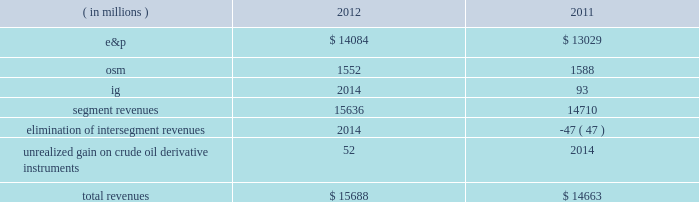Key operating and financial activities significant operating and financial activities during 2012 include : 2022 net proved reserve additions for the e&p and osm segments combined of 389 mmboe , for a 226 percent reserve replacement 2022 increased proved liquid hydrocarbon and synthetic crude oil reserves by 316 mmbbls , for a reserve replacement of 268 percent for these commodities 2022 recorded more than 95 percent average operational availability for operated e&p assets 2022 increased e&p net sales volumes , excluding libya , by 8 percent 2022 eagle ford shale average net sales volumes of 65 mboed for december 2012 , a fourfold increase over december 2011 2022 bakken shale average net sales volumes of 29 mboed , a 71 percent increase over last year 2022 resumed sales from libya and reached pre-conflict production levels 2022 international liquid hydrocarbon sales volumes , for which average realizations have exceeded wti , were 62 percent of net e&p liquid hydrocarbon sales 2022 closed $ 1 billion of acquisitions in the core of the eagle ford shale 2022 assumed operatorship of the vilje field located offshore norway 2022 signed agreements for new exploration positions in e.g. , gabon , kenya and ethiopia 2022 issued $ 1 billion of 3-year senior notes at 0.9 percent interest and $ 1 billion of 10-year senior notes at 2.8 percent interest some significant 2013 activities through february 22 , 2013 include : 2022 closed sale of our alaska assets in january 2013 2022 closed sale of our interest in the neptune gas plant in february 2013 consolidated results of operations : 2012 compared to 2011 consolidated income before income taxes was 38 percent higher in 2012 than consolidated income from continuing operations before income taxes were in 2011 , largely due to higher liquid hydrocarbon sales volumes in our e&p segment , partially offset by lower earnings from our osm and ig segments .
The 7 percent decrease in income from continuing operations included lower earnings in the u.k .
And e.g. , partially offset by higher earnings in libya .
Also , in 2011 we were not in an excess foreign tax credit position for the entire year as we were in 2012 .
The effective income tax rate for continuing operations was 74 percent in 2012 compared to 61 percent in 2011 .
Revenues are summarized in the table: .
E&p segment revenues increased $ 1055 million from 2011 to 2012 , primarily due to higher average liquid hydrocarbon sales volumes .
E&p segment revenues included a net realized gain on crude oil derivative instruments of $ 15 million in 2012 while the impact of derivatives was not significant in 2011 .
See item 8 .
Financial statements and supplementary data 2013 note 16 to the consolidated financial statement for more information about our crude oil derivative instruments .
Included in our e&p segment are supply optimization activities which include the purchase of commodities from third parties for resale .
See the cost of revenues discussion as revenues from supply optimization approximate the related costs .
Supply optimization serves to aggregate volumes in order to satisfy transportation commitments and to achieve flexibility within product .
What percentage of total revenues consited of e&p production in 2012? 
Computations: (14084 / 15688)
Answer: 0.89776. 